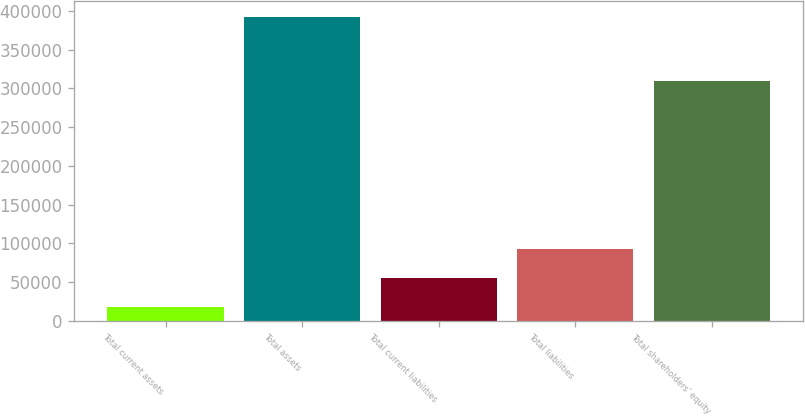Convert chart. <chart><loc_0><loc_0><loc_500><loc_500><bar_chart><fcel>Total current assets<fcel>Total assets<fcel>Total current liabilities<fcel>Total liabilities<fcel>Total shareholders' equity<nl><fcel>17824<fcel>392495<fcel>55291.1<fcel>92758.2<fcel>309354<nl></chart> 